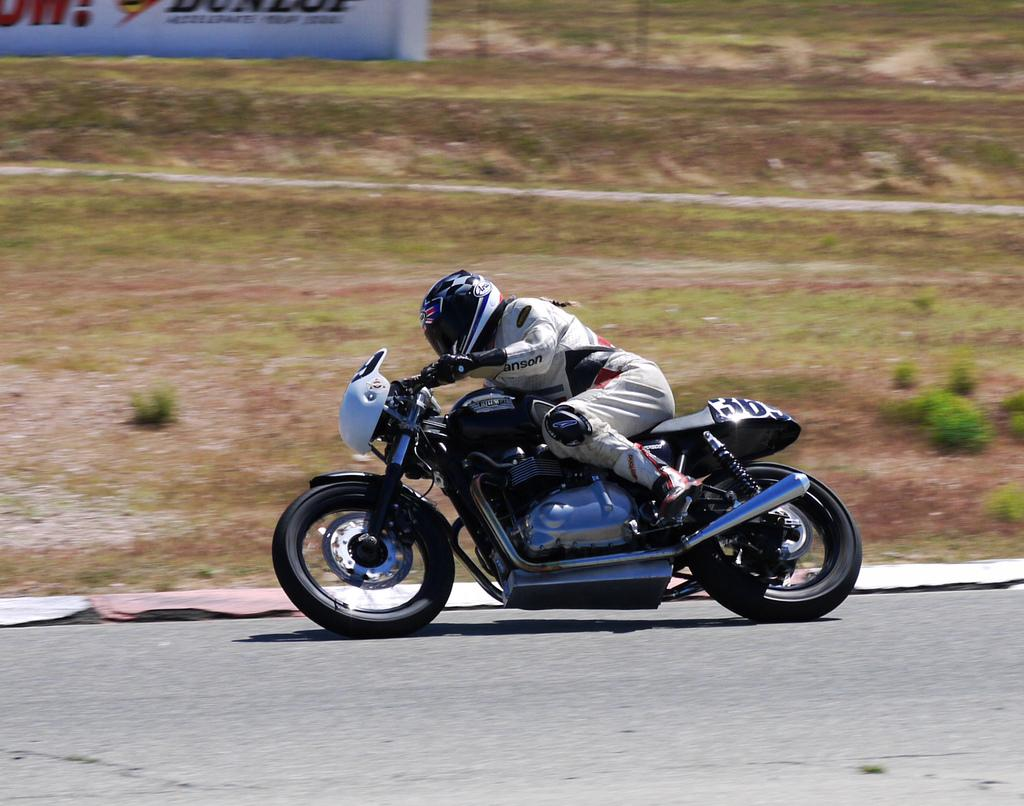What is the person in the image doing? The person is driving a motor vehicle in the image. Where is the vehicle located? The vehicle is on the road. What type of natural environment can be seen in the image? There are plants and grass in the image. What is the board with text used for in the image? The purpose of the board with text is not clear from the image, but it is present. What type of straw is being used to drink milk in the image? There is no straw or milk present in the image. 